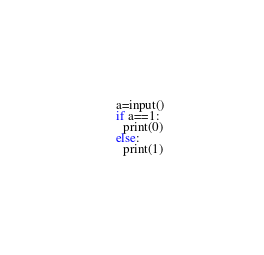Convert code to text. <code><loc_0><loc_0><loc_500><loc_500><_Python_>a=input()
if a==1:
  print(0)
else:
  print(1)</code> 